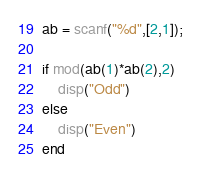Convert code to text. <code><loc_0><loc_0><loc_500><loc_500><_Octave_>ab = scanf("%d",[2,1]);
 
if mod(ab(1)*ab(2),2)
    disp("Odd")
else
    disp("Even")
end
</code> 